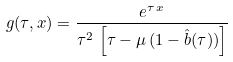Convert formula to latex. <formula><loc_0><loc_0><loc_500><loc_500>g ( \tau , x ) = \frac { e ^ { \tau \, x } } { \tau ^ { 2 } \, \left [ \tau - \mu \, ( 1 - \hat { b } ( \tau ) ) \right ] }</formula> 